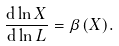<formula> <loc_0><loc_0><loc_500><loc_500>\frac { { \mathrm d } \ln X } { { \mathrm d } \ln L } = \beta ( X ) .</formula> 